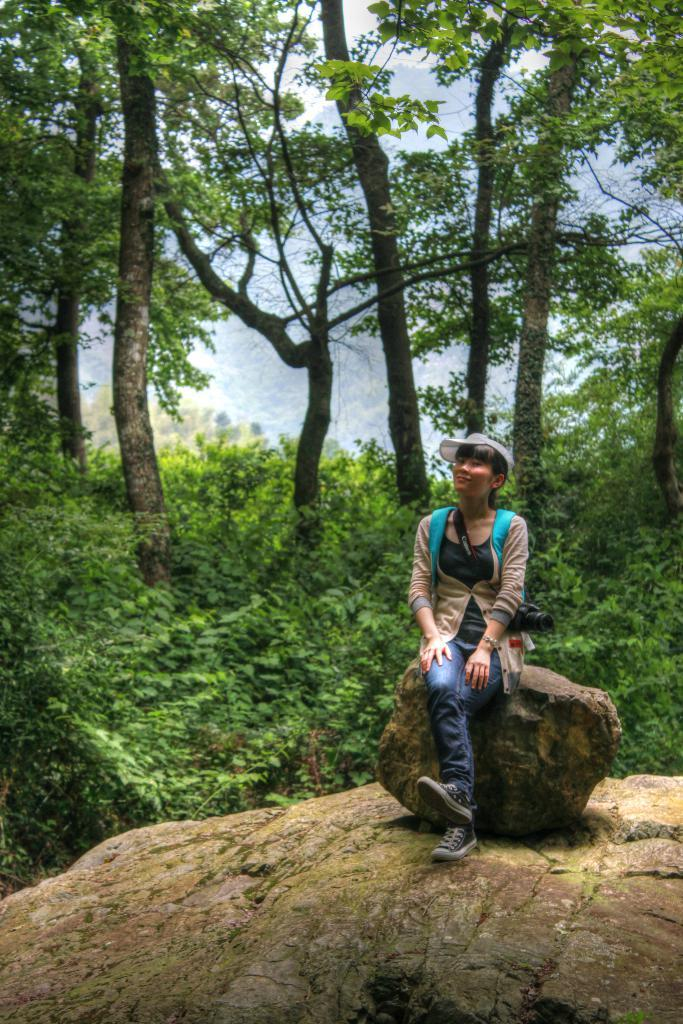Who is present in the image? There is a woman in the image. What is the woman sitting on? The woman is sitting on a stone. What can be seen in the background of the image? There are trees and plants in the background of the image. What is the woman's emotional state as depicted in the image? The image does not provide any information about the woman's emotional state, so it cannot be determined from the image. 